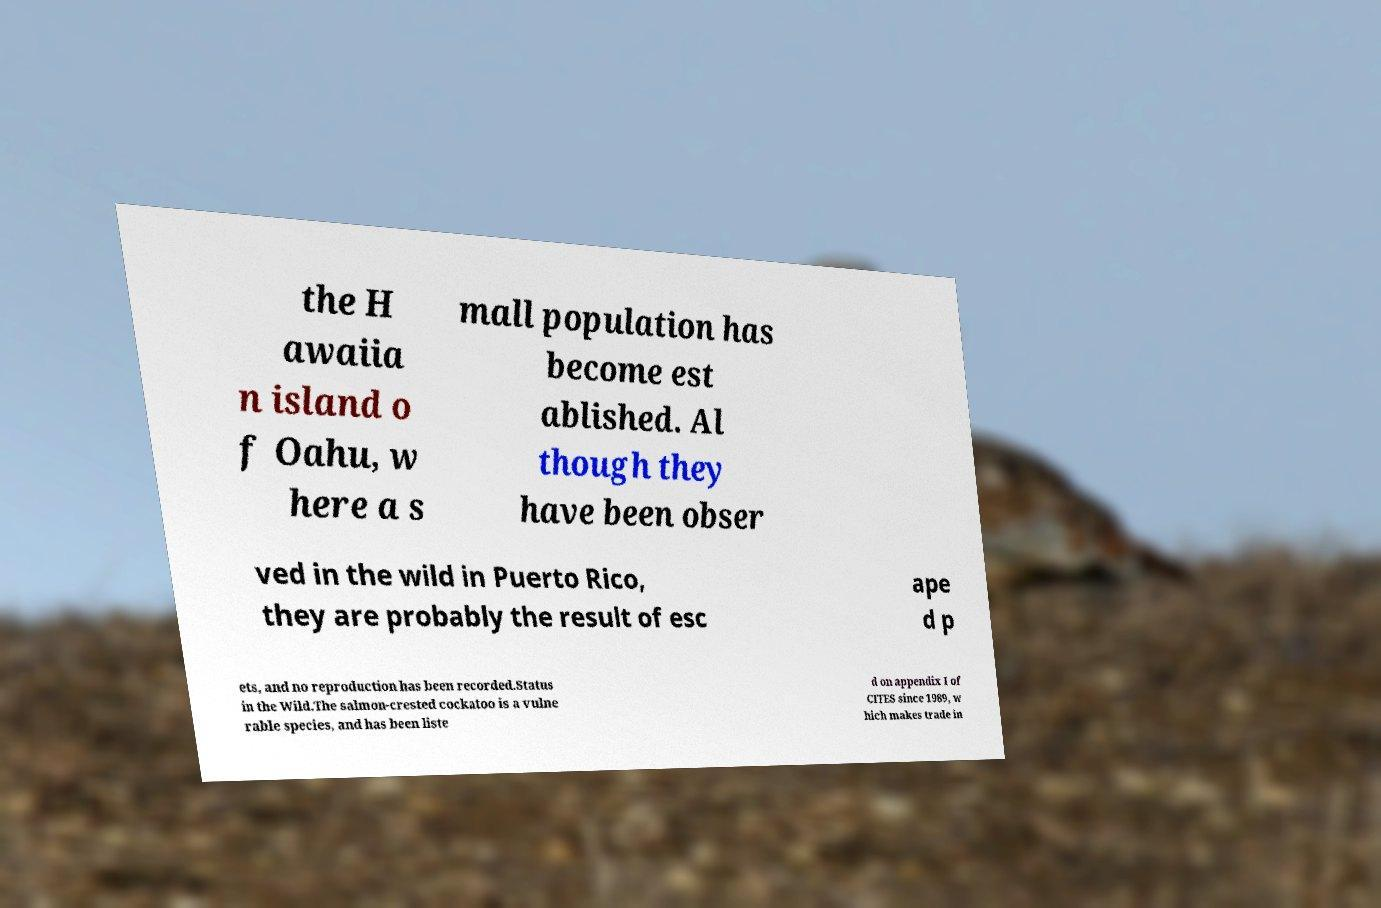Could you extract and type out the text from this image? the H awaiia n island o f Oahu, w here a s mall population has become est ablished. Al though they have been obser ved in the wild in Puerto Rico, they are probably the result of esc ape d p ets, and no reproduction has been recorded.Status in the Wild.The salmon-crested cockatoo is a vulne rable species, and has been liste d on appendix I of CITES since 1989, w hich makes trade in 